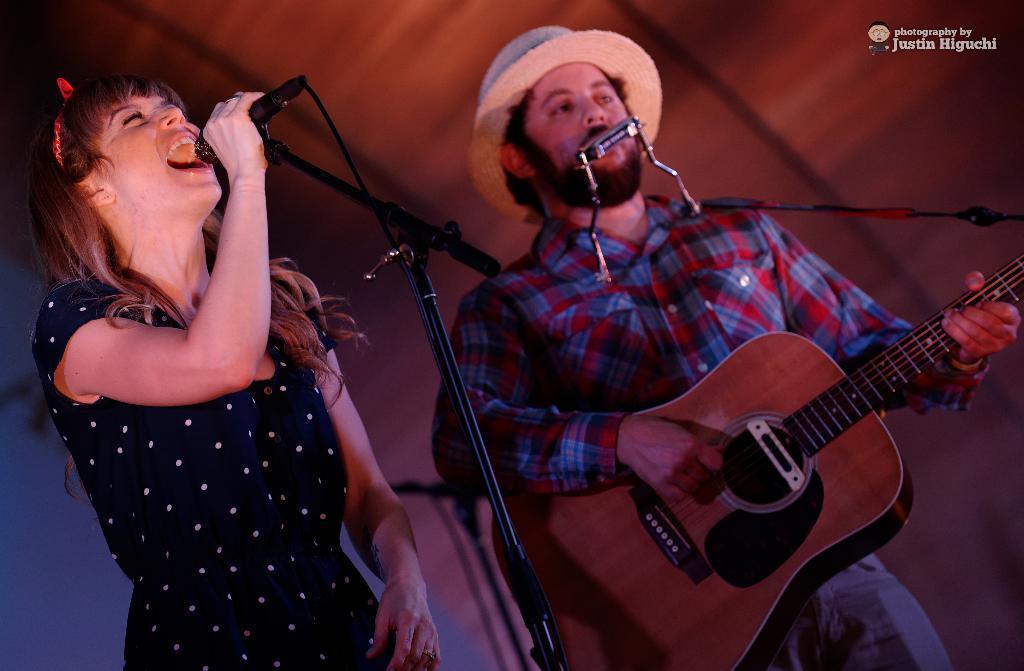Please provide a concise description of this image. The two persons are standing on a stage. They are playing a musical instruments. 